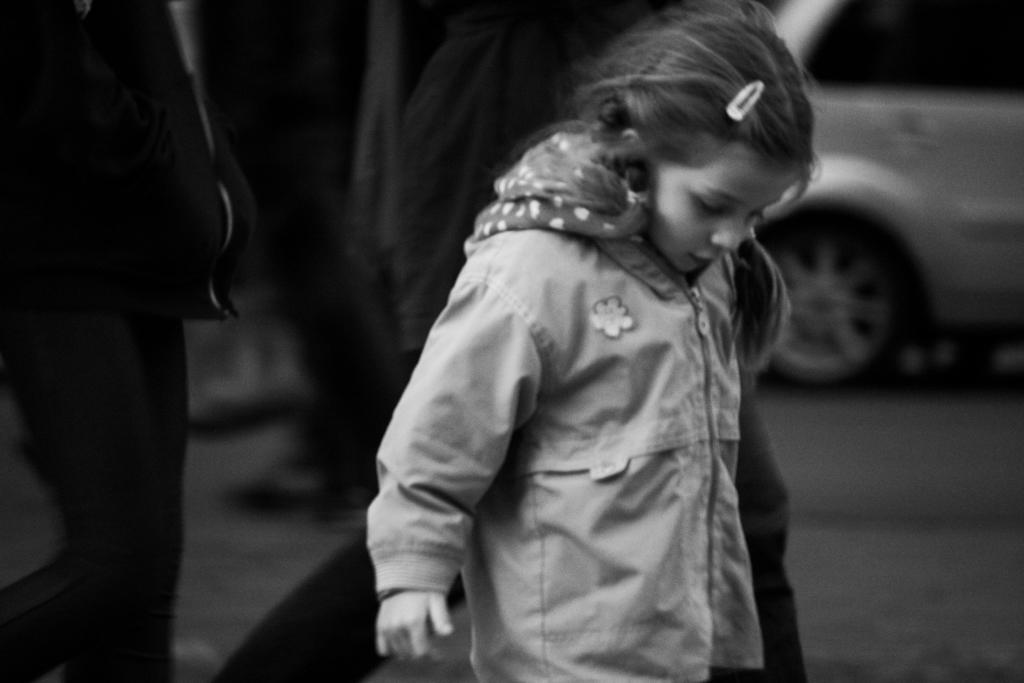What is the color scheme of the image? The image is black and white. Who is the main subject in the image? There is a girl in the middle of the image. What can be seen on the right side of the image? There is a car on the right side top of the image. How many other persons are in the image besides the girl? There are two other persons standing on the left side of the image. Where are the two other persons located in the image? The two persons are on the floor. What type of plane can be seen flying in the image? There is no plane visible in the image; it is a black and white image with a girl, a car, and two other persons. What is the weight of the scale in the image? There is no scale present in the image. 